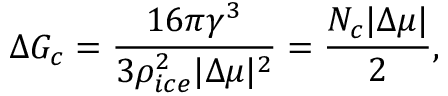<formula> <loc_0><loc_0><loc_500><loc_500>\Delta G _ { c } = \frac { 1 6 \pi \gamma ^ { 3 } } { 3 \rho _ { i c e } ^ { 2 } | \Delta \mu | ^ { 2 } } = \frac { N _ { c } | \Delta \mu | } { 2 } ,</formula> 